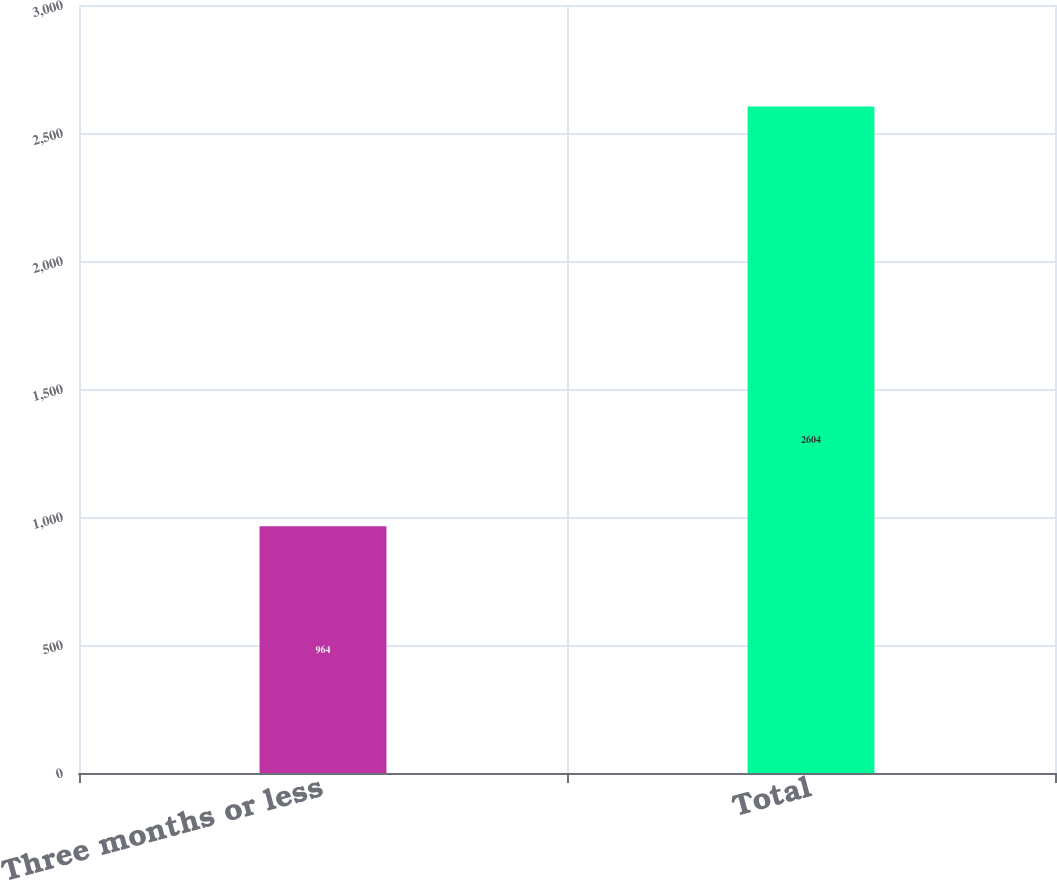<chart> <loc_0><loc_0><loc_500><loc_500><bar_chart><fcel>Three months or less<fcel>Total<nl><fcel>964<fcel>2604<nl></chart> 